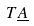<formula> <loc_0><loc_0><loc_500><loc_500>T \underline { A }</formula> 